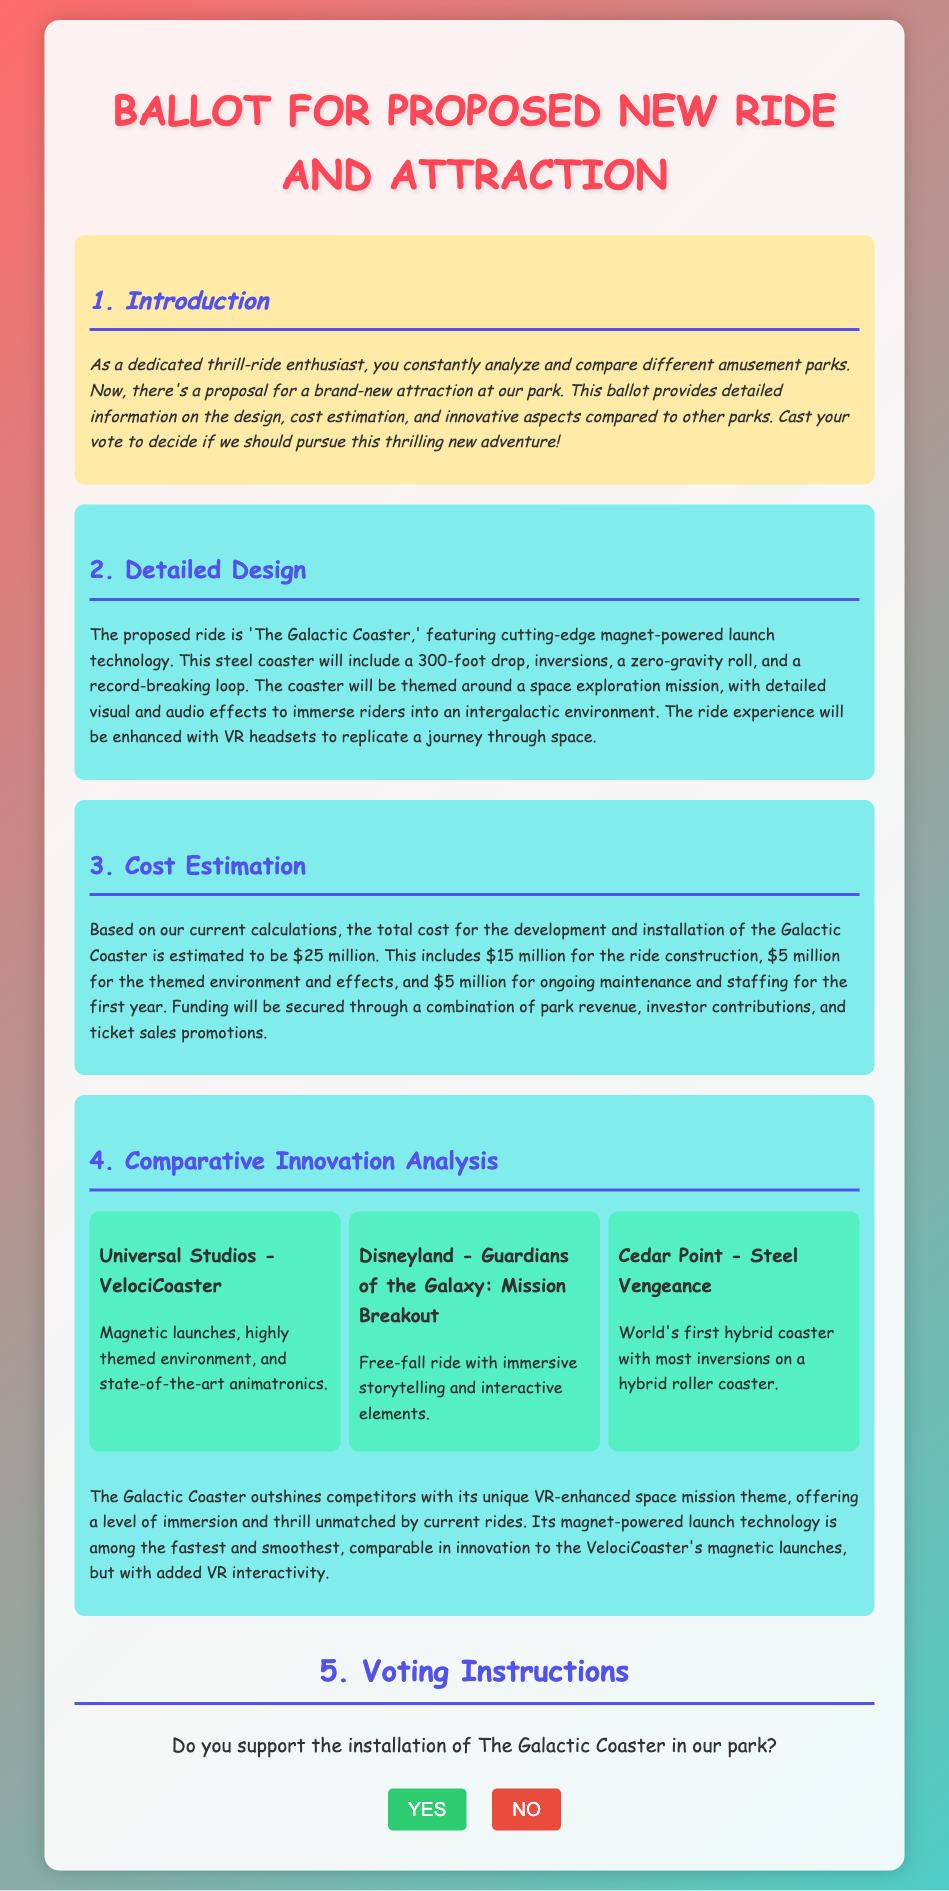What is the name of the proposed ride? The proposal specifically mentions the new ride as 'The Galactic Coaster.'
Answer: The Galactic Coaster What is the height of the drop? The document states there is a 300-foot drop in the ride.
Answer: 300-foot How much is the estimated cost for the ride construction? The estimated cost for the ride construction is mentioned as $15 million.
Answer: $15 million Which attraction is compared to the proposed ride regarding magnetic launches? The comparison mentions the Universal Studios' VelociCoaster as having magnetic launches.
Answer: VelociCoaster What technology does the Galactic Coaster feature for launching? The document states that the ride features magnet-powered launch technology.
Answer: Magnet-powered What unique aspect does the Galactic Coaster offer that competitors do not? The proposal highlights the unique VR-enhanced space mission theme as unmatched by current rides.
Answer: VR-enhanced space mission theme How much is estimated for ongoing maintenance and staffing for the first year? The document mentions an estimate of $5 million for ongoing maintenance and staffing.
Answer: $5 million What is the total estimated cost for the Galactic Coaster? The total cost for development and installation is estimated to be $25 million.
Answer: $25 million What type of document is this ballot classified as? This document is a ballot for proposing a new ride and attraction.
Answer: Ballot 